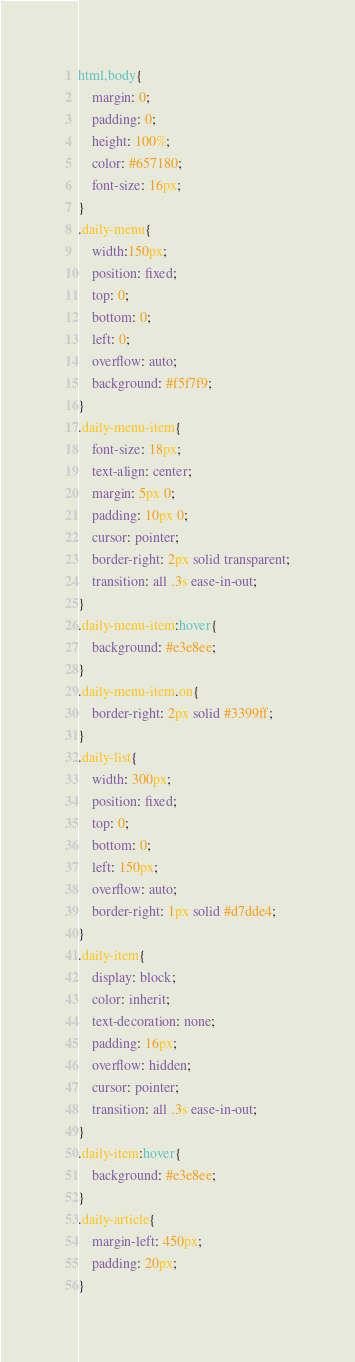<code> <loc_0><loc_0><loc_500><loc_500><_CSS_>html,body{
    margin: 0;
    padding: 0;
    height: 100%;
    color: #657180;
    font-size: 16px;
}
.daily-menu{
    width:150px;
    position: fixed;
    top: 0;
    bottom: 0;
    left: 0;
    overflow: auto;
    background: #f5f7f9;
}
.daily-menu-item{
    font-size: 18px;
    text-align: center;
    margin: 5px 0;
    padding: 10px 0;
    cursor: pointer;
    border-right: 2px solid transparent;
    transition: all .3s ease-in-out;
}
.daily-menu-item:hover{
    background: #e3e8ee;
}
.daily-menu-item.on{
    border-right: 2px solid #3399ff;
}
.daily-list{
    width: 300px;
    position: fixed;
    top: 0;
    bottom: 0;
    left: 150px;
    overflow: auto;
    border-right: 1px solid #d7dde4;
}
.daily-item{
    display: block;
    color: inherit;
    text-decoration: none;
    padding: 16px;
    overflow: hidden;
    cursor: pointer;
    transition: all .3s ease-in-out;
}
.daily-item:hover{
    background: #e3e8ee;
}
.daily-article{
    margin-left: 450px;
    padding: 20px;
}</code> 